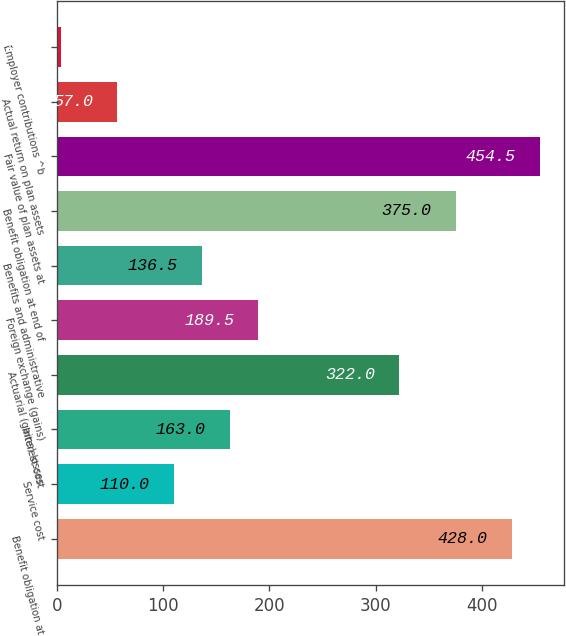Convert chart. <chart><loc_0><loc_0><loc_500><loc_500><bar_chart><fcel>Benefit obligation at<fcel>Service cost<fcel>Interest cost<fcel>Actuarial (gains) losses<fcel>Foreign exchange (gains)<fcel>Benefits and administrative<fcel>Benefit obligation at end of<fcel>Fair value of plan assets at<fcel>Actual return on plan assets<fcel>Employer contributions ^b<nl><fcel>428<fcel>110<fcel>163<fcel>322<fcel>189.5<fcel>136.5<fcel>375<fcel>454.5<fcel>57<fcel>4<nl></chart> 